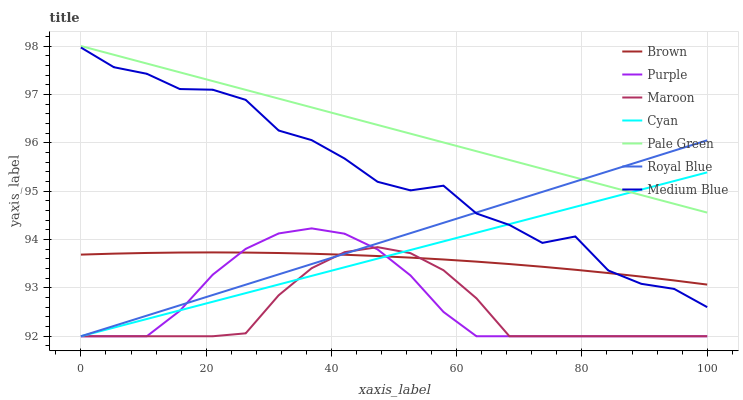Does Maroon have the minimum area under the curve?
Answer yes or no. Yes. Does Pale Green have the maximum area under the curve?
Answer yes or no. Yes. Does Purple have the minimum area under the curve?
Answer yes or no. No. Does Purple have the maximum area under the curve?
Answer yes or no. No. Is Pale Green the smoothest?
Answer yes or no. Yes. Is Medium Blue the roughest?
Answer yes or no. Yes. Is Purple the smoothest?
Answer yes or no. No. Is Purple the roughest?
Answer yes or no. No. Does Purple have the lowest value?
Answer yes or no. Yes. Does Medium Blue have the lowest value?
Answer yes or no. No. Does Pale Green have the highest value?
Answer yes or no. Yes. Does Purple have the highest value?
Answer yes or no. No. Is Purple less than Pale Green?
Answer yes or no. Yes. Is Medium Blue greater than Purple?
Answer yes or no. Yes. Does Maroon intersect Brown?
Answer yes or no. Yes. Is Maroon less than Brown?
Answer yes or no. No. Is Maroon greater than Brown?
Answer yes or no. No. Does Purple intersect Pale Green?
Answer yes or no. No. 